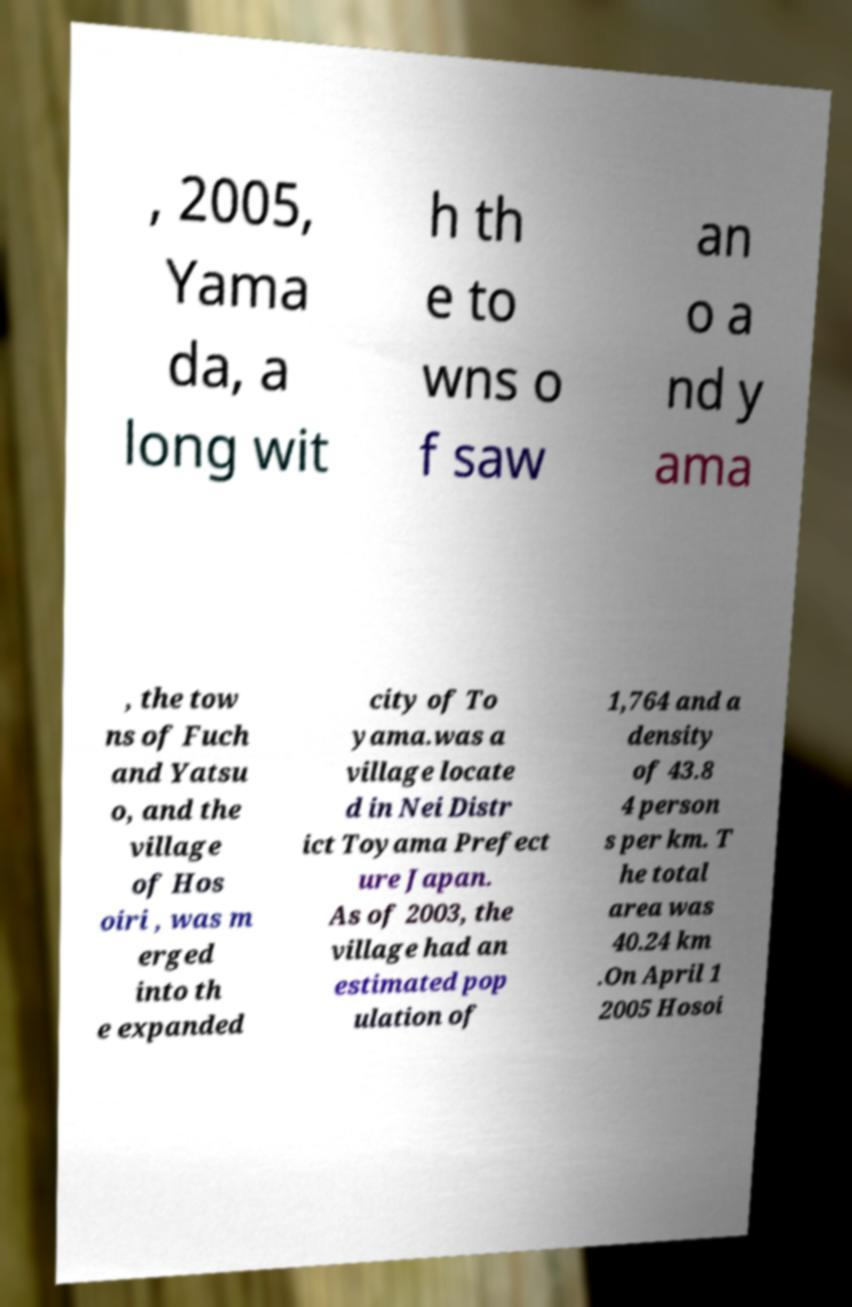There's text embedded in this image that I need extracted. Can you transcribe it verbatim? , 2005, Yama da, a long wit h th e to wns o f saw an o a nd y ama , the tow ns of Fuch and Yatsu o, and the village of Hos oiri , was m erged into th e expanded city of To yama.was a village locate d in Nei Distr ict Toyama Prefect ure Japan. As of 2003, the village had an estimated pop ulation of 1,764 and a density of 43.8 4 person s per km. T he total area was 40.24 km .On April 1 2005 Hosoi 